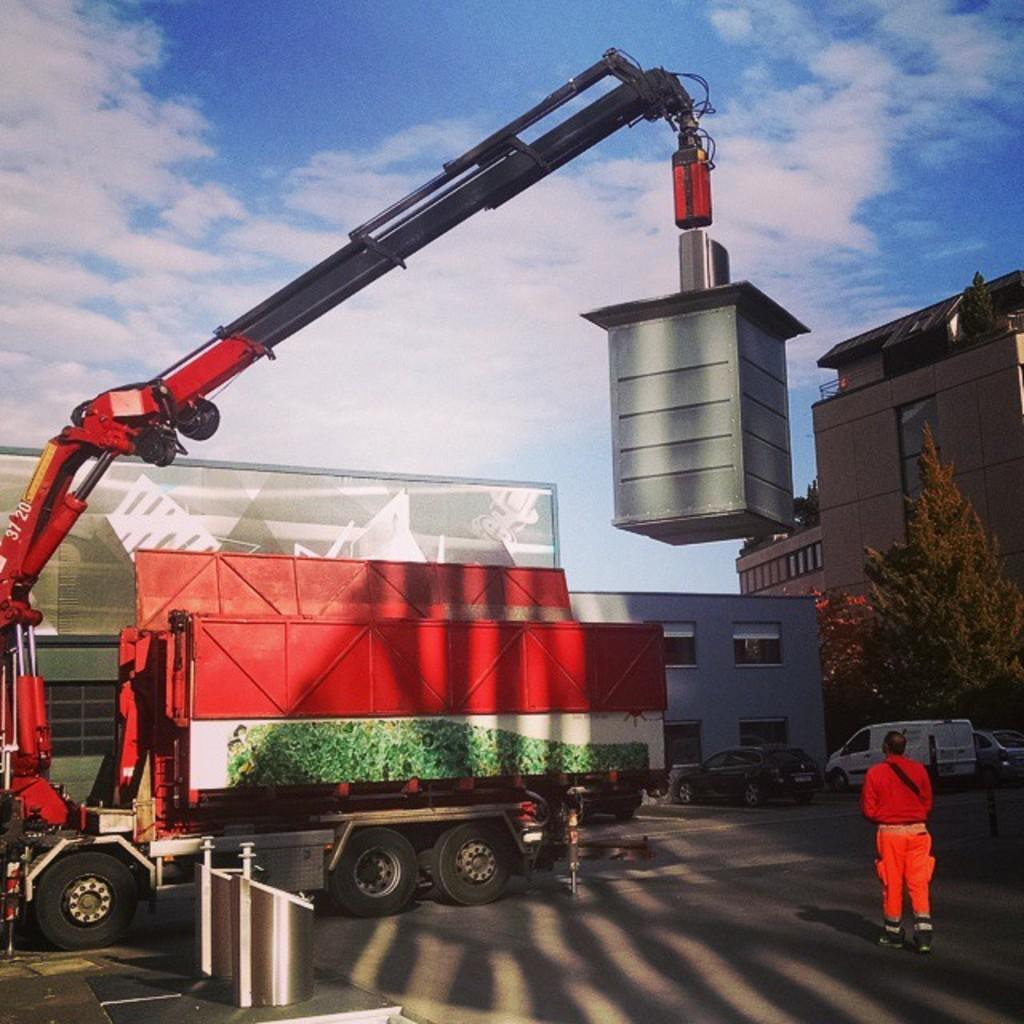<image>
Describe the image concisely. A red crane with the numbers 37 20 on it is lifting a heavy object 